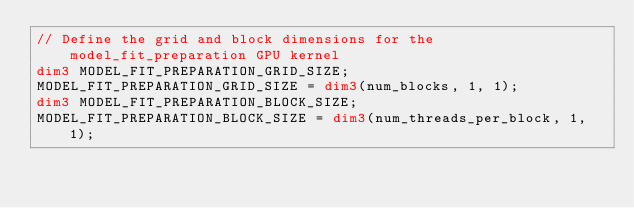Convert code to text. <code><loc_0><loc_0><loc_500><loc_500><_Cuda_>// Define the grid and block dimensions for the model_fit_preparation GPU kernel
dim3 MODEL_FIT_PREPARATION_GRID_SIZE;
MODEL_FIT_PREPARATION_GRID_SIZE = dim3(num_blocks, 1, 1);
dim3 MODEL_FIT_PREPARATION_BLOCK_SIZE;
MODEL_FIT_PREPARATION_BLOCK_SIZE = dim3(num_threads_per_block, 1, 1);</code> 